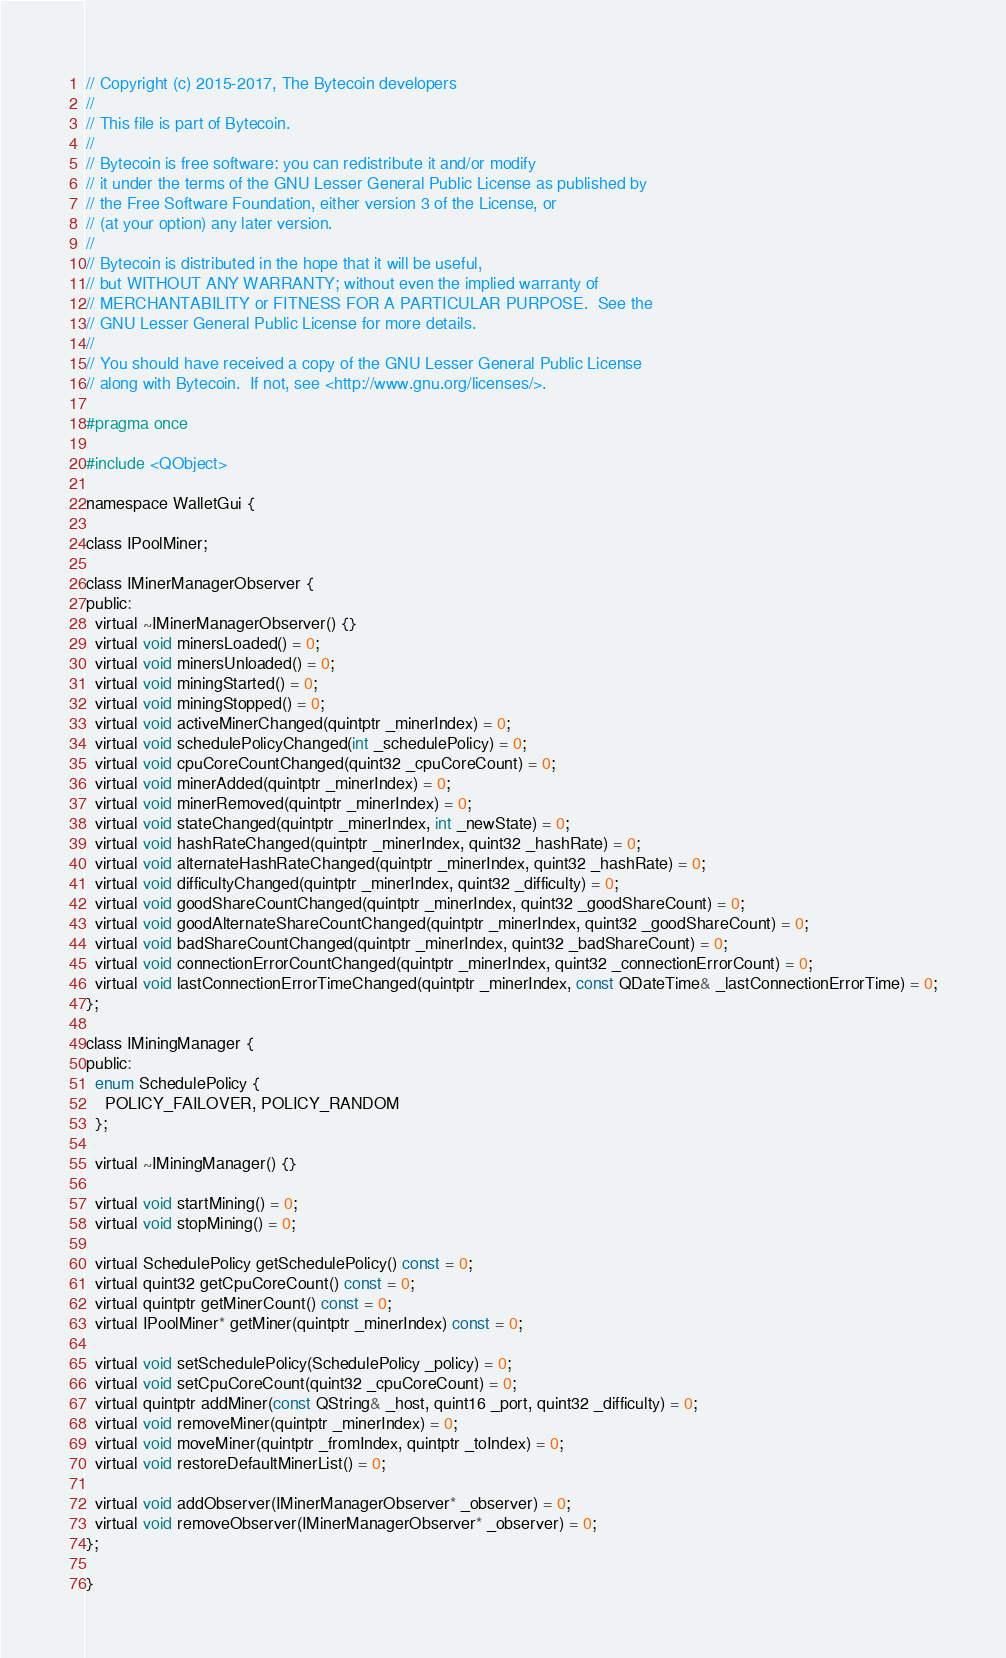<code> <loc_0><loc_0><loc_500><loc_500><_C_>// Copyright (c) 2015-2017, The Bytecoin developers
//
// This file is part of Bytecoin.
//
// Bytecoin is free software: you can redistribute it and/or modify
// it under the terms of the GNU Lesser General Public License as published by
// the Free Software Foundation, either version 3 of the License, or
// (at your option) any later version.
//
// Bytecoin is distributed in the hope that it will be useful,
// but WITHOUT ANY WARRANTY; without even the implied warranty of
// MERCHANTABILITY or FITNESS FOR A PARTICULAR PURPOSE.  See the
// GNU Lesser General Public License for more details.
//
// You should have received a copy of the GNU Lesser General Public License
// along with Bytecoin.  If not, see <http://www.gnu.org/licenses/>.

#pragma once

#include <QObject>

namespace WalletGui {

class IPoolMiner;

class IMinerManagerObserver {
public:
  virtual ~IMinerManagerObserver() {}
  virtual void minersLoaded() = 0;
  virtual void minersUnloaded() = 0;
  virtual void miningStarted() = 0;
  virtual void miningStopped() = 0;
  virtual void activeMinerChanged(quintptr _minerIndex) = 0;
  virtual void schedulePolicyChanged(int _schedulePolicy) = 0;
  virtual void cpuCoreCountChanged(quint32 _cpuCoreCount) = 0;
  virtual void minerAdded(quintptr _minerIndex) = 0;
  virtual void minerRemoved(quintptr _minerIndex) = 0;
  virtual void stateChanged(quintptr _minerIndex, int _newState) = 0;
  virtual void hashRateChanged(quintptr _minerIndex, quint32 _hashRate) = 0;
  virtual void alternateHashRateChanged(quintptr _minerIndex, quint32 _hashRate) = 0;
  virtual void difficultyChanged(quintptr _minerIndex, quint32 _difficulty) = 0;
  virtual void goodShareCountChanged(quintptr _minerIndex, quint32 _goodShareCount) = 0;
  virtual void goodAlternateShareCountChanged(quintptr _minerIndex, quint32 _goodShareCount) = 0;
  virtual void badShareCountChanged(quintptr _minerIndex, quint32 _badShareCount) = 0;
  virtual void connectionErrorCountChanged(quintptr _minerIndex, quint32 _connectionErrorCount) = 0;
  virtual void lastConnectionErrorTimeChanged(quintptr _minerIndex, const QDateTime& _lastConnectionErrorTime) = 0;
};

class IMiningManager {
public:
  enum SchedulePolicy {
    POLICY_FAILOVER, POLICY_RANDOM
  };

  virtual ~IMiningManager() {}

  virtual void startMining() = 0;
  virtual void stopMining() = 0;

  virtual SchedulePolicy getSchedulePolicy() const = 0;
  virtual quint32 getCpuCoreCount() const = 0;
  virtual quintptr getMinerCount() const = 0;
  virtual IPoolMiner* getMiner(quintptr _minerIndex) const = 0;

  virtual void setSchedulePolicy(SchedulePolicy _policy) = 0;
  virtual void setCpuCoreCount(quint32 _cpuCoreCount) = 0;
  virtual quintptr addMiner(const QString& _host, quint16 _port, quint32 _difficulty) = 0;
  virtual void removeMiner(quintptr _minerIndex) = 0;
  virtual void moveMiner(quintptr _fromIndex, quintptr _toIndex) = 0;
  virtual void restoreDefaultMinerList() = 0;

  virtual void addObserver(IMinerManagerObserver* _observer) = 0;
  virtual void removeObserver(IMinerManagerObserver* _observer) = 0;
};

}
</code> 